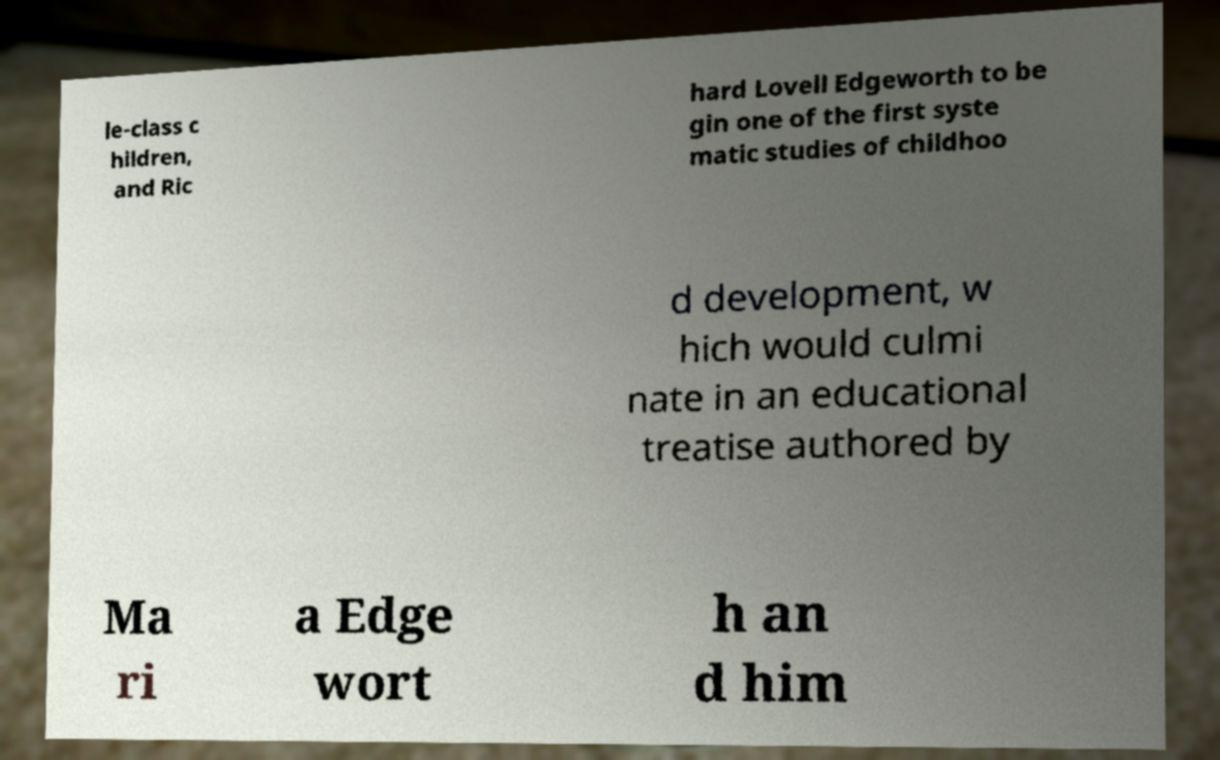Can you accurately transcribe the text from the provided image for me? le-class c hildren, and Ric hard Lovell Edgeworth to be gin one of the first syste matic studies of childhoo d development, w hich would culmi nate in an educational treatise authored by Ma ri a Edge wort h an d him 